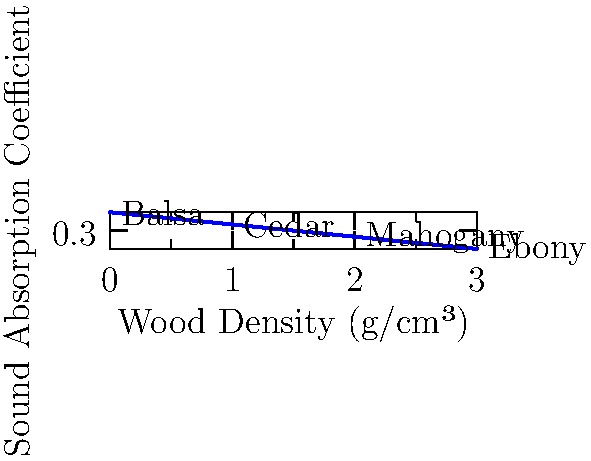The graph shows the relationship between wood density and sound absorption coefficient for different types of wood commonly used in African musical instruments. Which wood type would be most suitable for creating a resonant body in a drum, and why? To answer this question, we need to understand the relationship between wood density, sound absorption, and resonance:

1. The graph shows an inverse relationship between wood density and sound absorption coefficient.
2. A lower sound absorption coefficient means that the material reflects more sound rather than absorbing it.
3. For a resonant body in a drum, we want a material that reflects sound well to create a strong, sustained tone.
4. Looking at the graph:
   - Balsa has the highest absorption coefficient (0.45) and lowest density
   - Cedar has the second-highest absorption coefficient (0.35)
   - Mahogany has a lower absorption coefficient (0.25)
   - Ebony has the lowest absorption coefficient (0.15) and highest density

5. Among these options, ebony would be the most suitable for creating a resonant body in a drum because:
   - It has the lowest sound absorption coefficient, meaning it will reflect more sound.
   - Its high density contributes to its ability to produce a clear, strong tone.
   - The reflected sound waves will reinforce each other, creating a more sustained and resonant sound.

6. While ebony is the best choice for resonance, it's worth noting that other factors like cost, availability, and ease of crafting also play a role in instrument making. Mahogany, for example, is often used as a more affordable alternative that still provides good resonance.
Answer: Ebony, due to its low sound absorption coefficient and high density. 